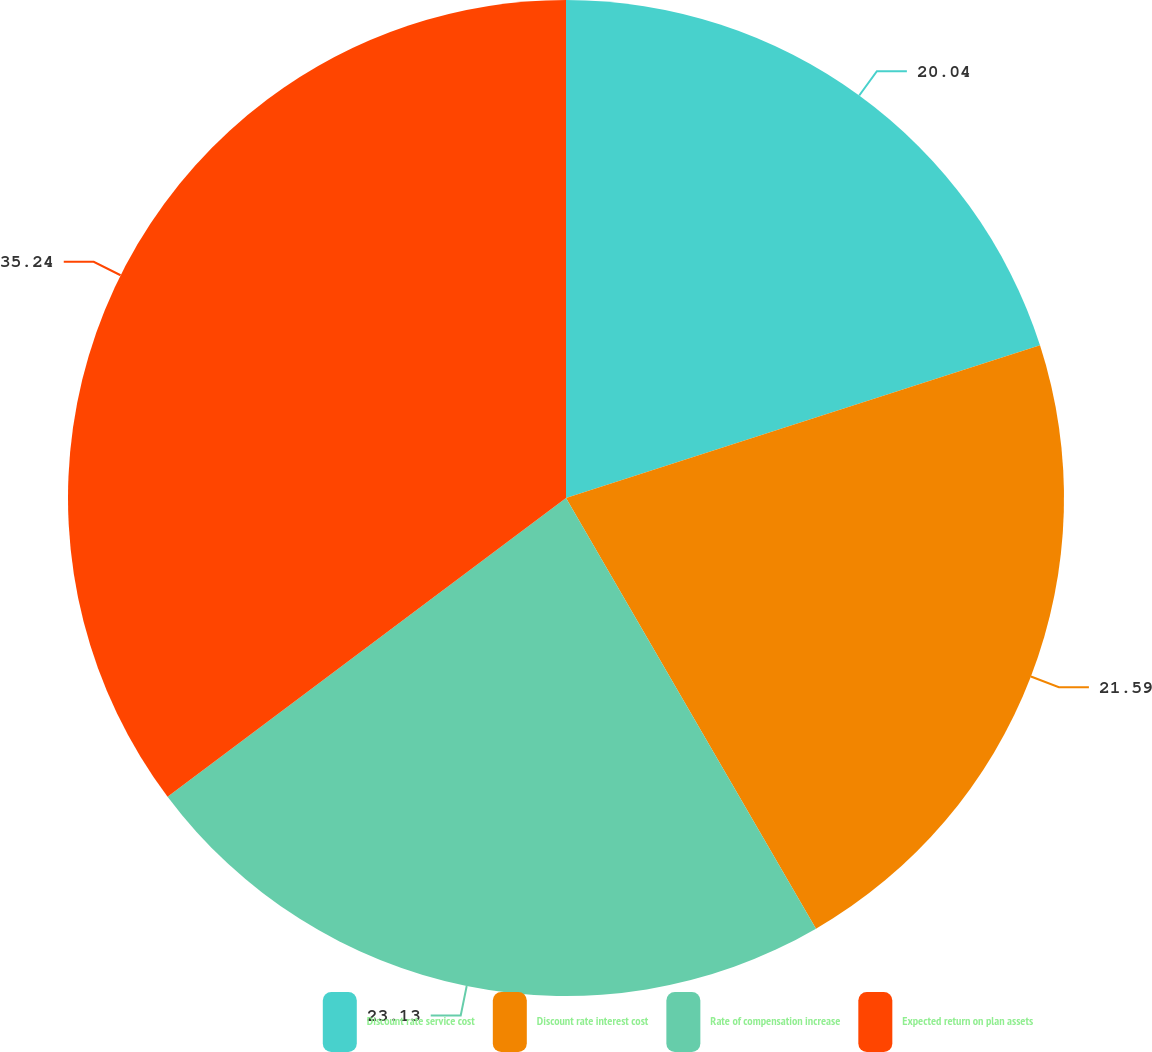Convert chart to OTSL. <chart><loc_0><loc_0><loc_500><loc_500><pie_chart><fcel>Discount rate service cost<fcel>Discount rate interest cost<fcel>Rate of compensation increase<fcel>Expected return on plan assets<nl><fcel>20.04%<fcel>21.59%<fcel>23.13%<fcel>35.24%<nl></chart> 